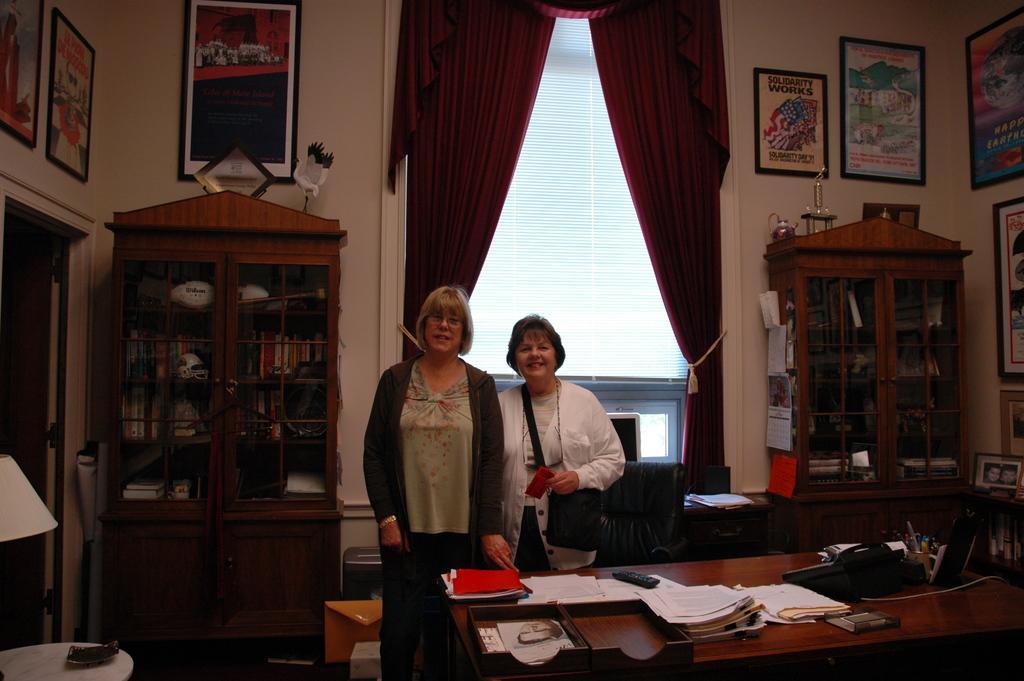In one or two sentences, can you explain what this image depicts? The image is taken inside a room. In the center of the image there are two ladies standing. There is a table before them and there are some papers, files, remote, telephone pen holder and a box placed on a table. There is a chair. On the left there is a lamp placed on the table behind that there is a cup board we can also see a door and wall frames. In the background there is a window and a curtain. 